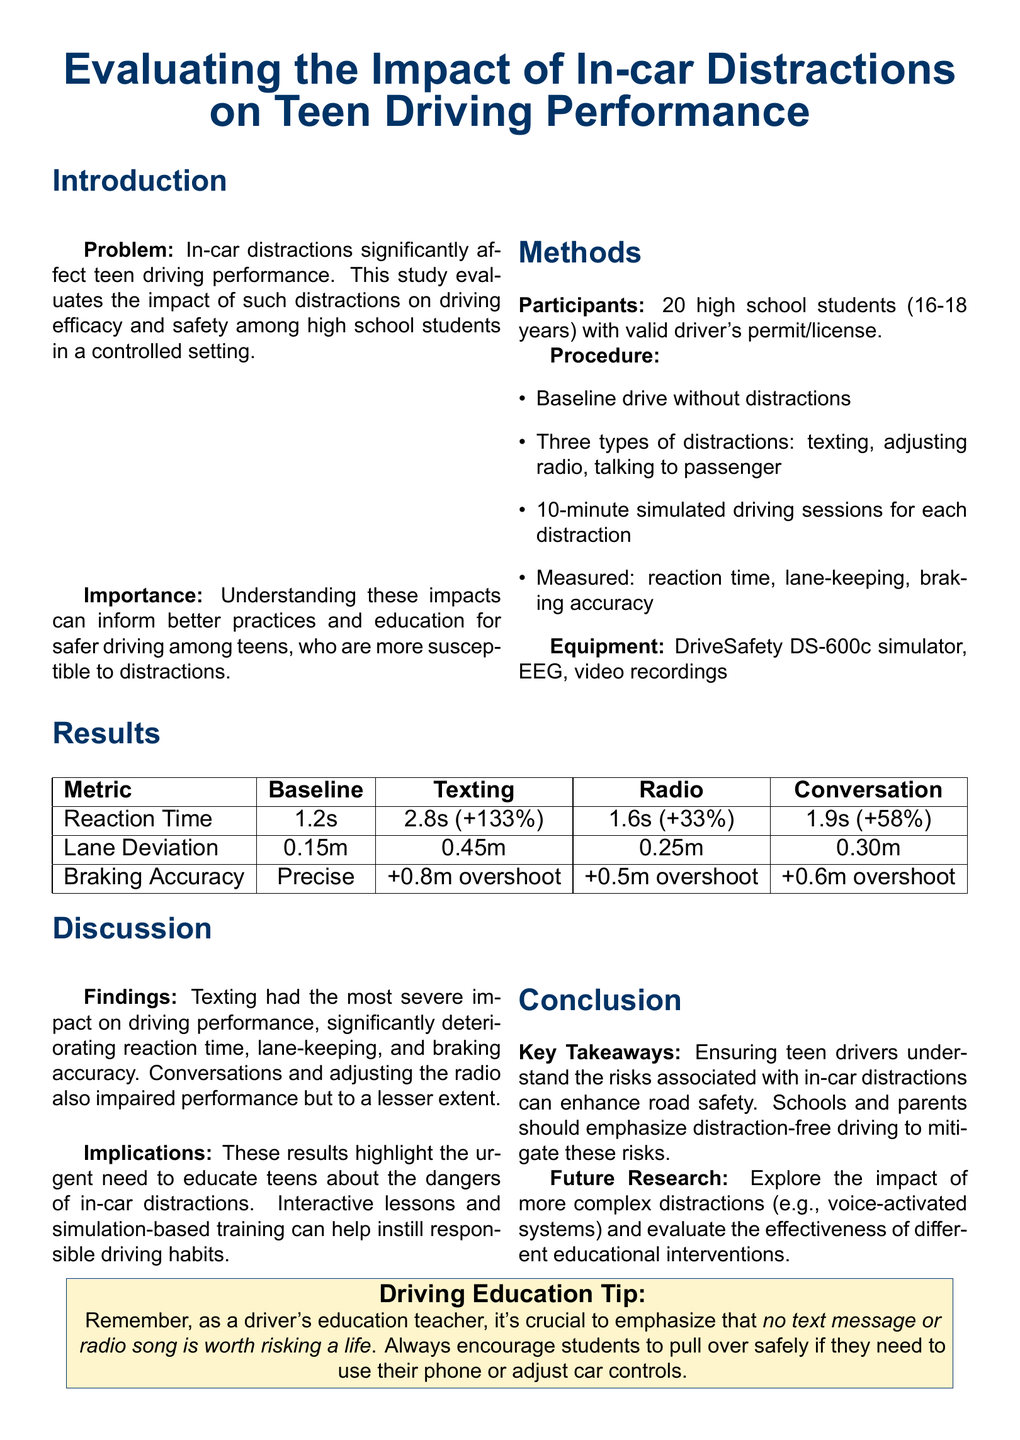What is the problem addressed in the study? The study addresses the significant effect of in-car distractions on teen driving performance.
Answer: In-car distractions Who were the participants in the study? The participants were high school students aged 16-18 years with valid driving permits or licenses.
Answer: 20 high school students What is the baseline reaction time recorded in the study? The baseline reaction time measures the performance without distractions. According to the results, it was 1.2 seconds.
Answer: 1.2s Which distraction showed the most severe impact on driving performance? The document states that texting had the most severe impact on driving performance among the distractions tested.
Answer: Texting What was the lane deviation caused by adjusting the radio? Lane deviation refers to how much drivers strayed from their lane, and adjusting the radio resulted in a lane deviation of 0.25 meters.
Answer: 0.25m What educational approach is suggested for improving teen driving habits? The document recommends interactive lessons and simulation-based training to instill responsible driving habits.
Answer: Interactive lessons How much did texting increase the reaction time compared to the baseline? The increase in reaction time due to texting was significant enough to note a change of 133 percent.
Answer: +133% What do the findings imply about educating teens on distractions? The implications suggest that there is an urgent need to educate teens about the dangers of in-car distractions.
Answer: Urgent need What recommendation does the report provide to teen drivers regarding texting? The report recommends that students be encouraged to pull over safely if they need to use their phone or adjust car controls.
Answer: Pull over safely 